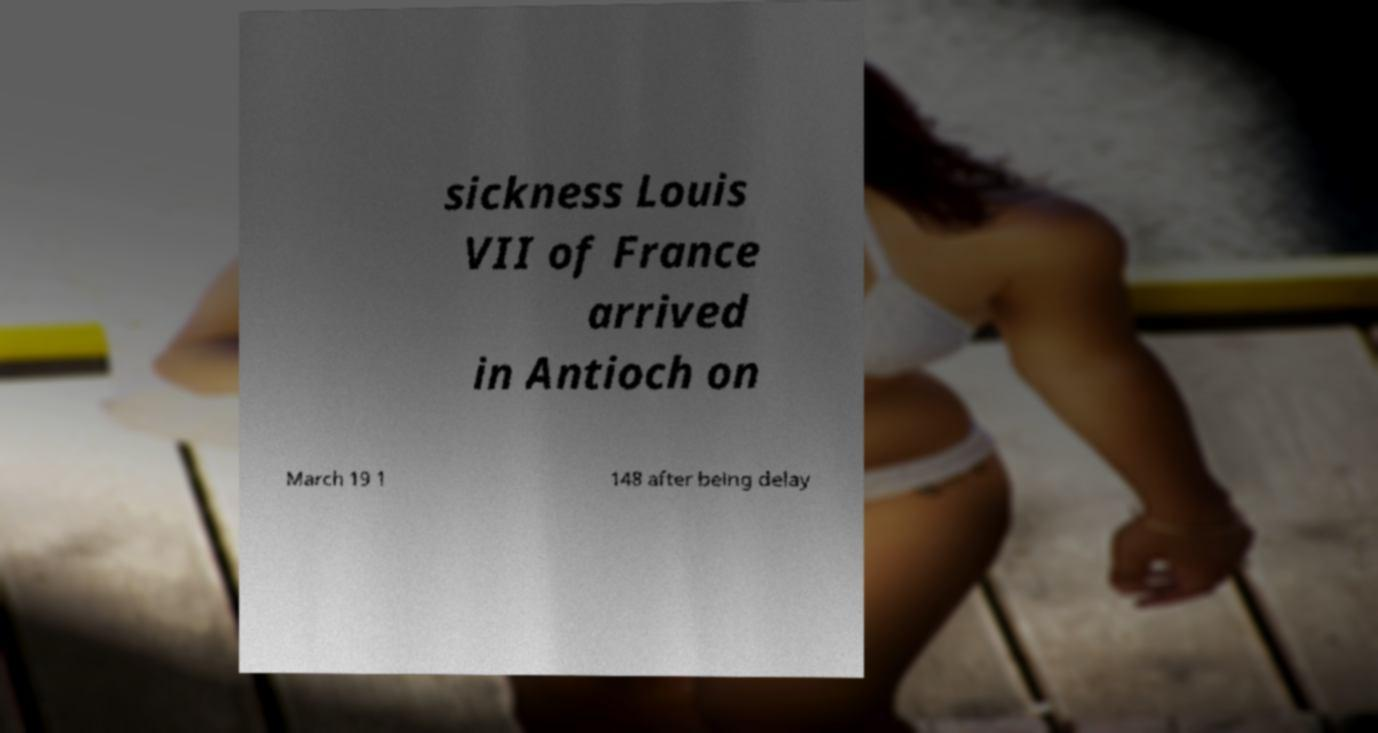What messages or text are displayed in this image? I need them in a readable, typed format. sickness Louis VII of France arrived in Antioch on March 19 1 148 after being delay 